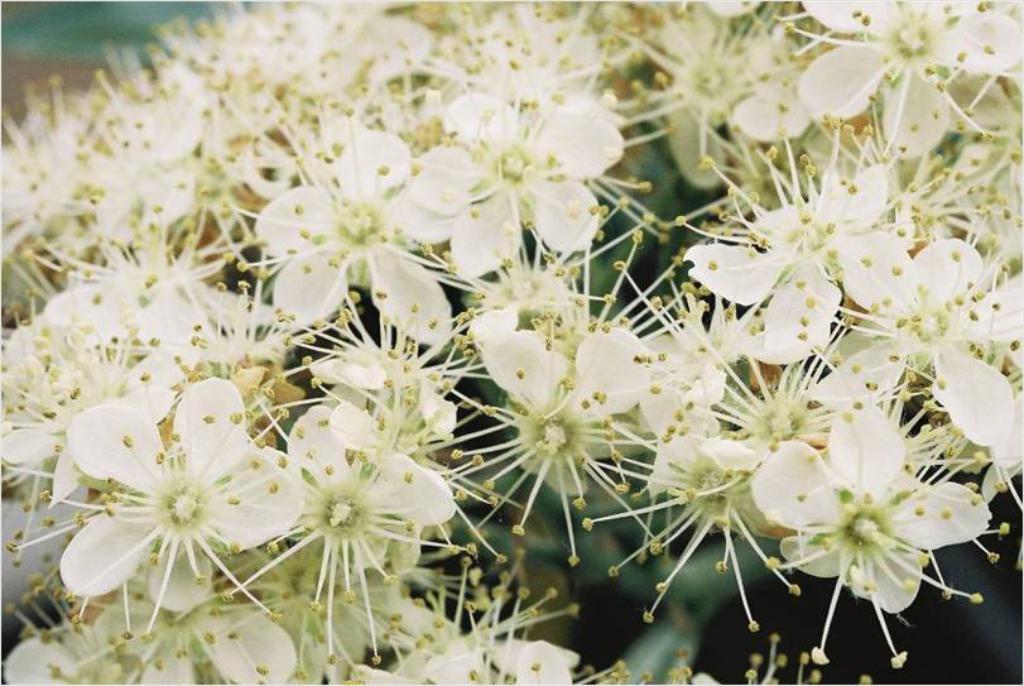Could you give a brief overview of what you see in this image? There are white color flowers in the image. 